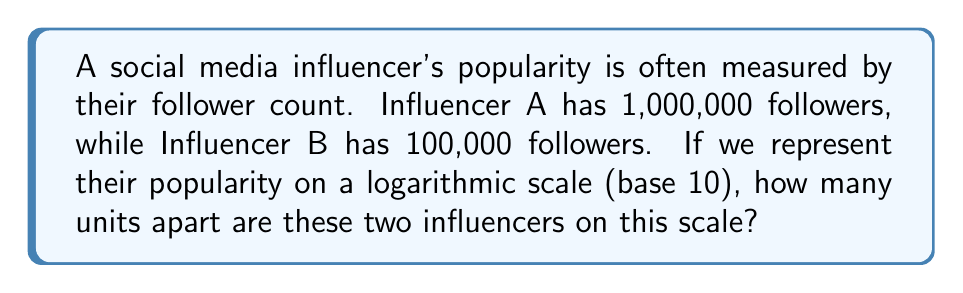Could you help me with this problem? To solve this problem, we need to follow these steps:

1. Convert the follower counts to logarithms (base 10):
   For Influencer A: $\log_{10}(1,000,000)$
   For Influencer B: $\log_{10}(100,000)$

2. Simplify the logarithms:
   Influencer A: $\log_{10}(1,000,000) = \log_{10}(10^6) = 6$
   Influencer B: $\log_{10}(100,000) = \log_{10}(10^5) = 5$

3. Calculate the difference between the two logarithmic values:
   $6 - 5 = 1$

This difference of 1 represents one unit on the logarithmic scale.

Note: Each unit on a logarithmic scale (base 10) represents a tenfold increase in the original value. This is why a difference of 1,000,000 and 100,000 followers becomes just 1 unit on the logarithmic scale.
Answer: 1 unit 